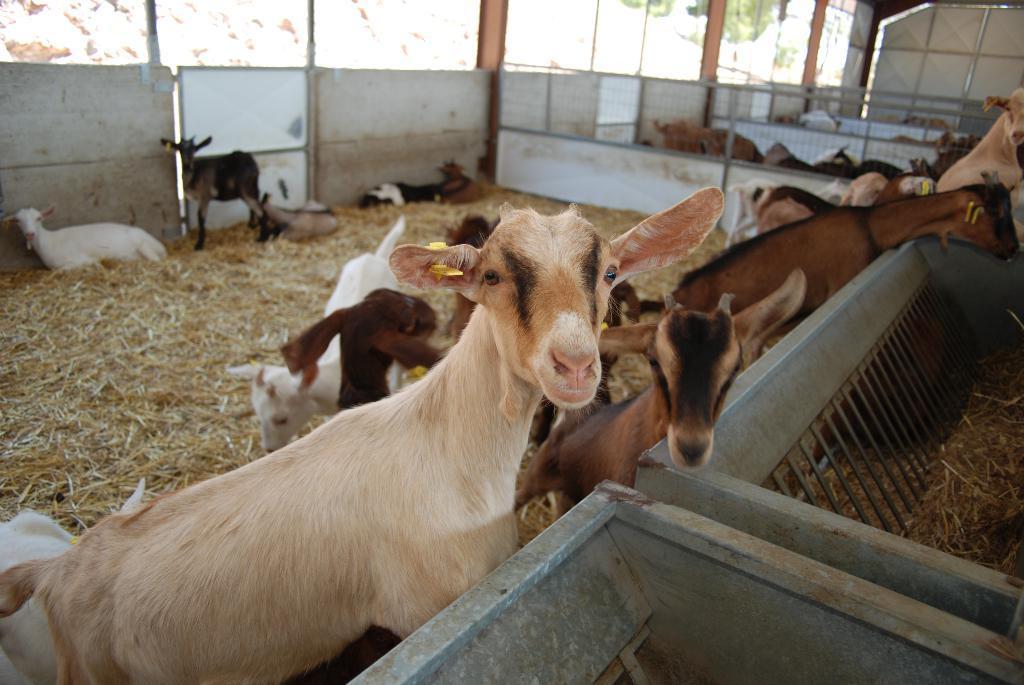Could you give a brief overview of what you see in this image? In the image there are many goats inside a fence with grass on the floor and in the back there are many goats inside the fence. 